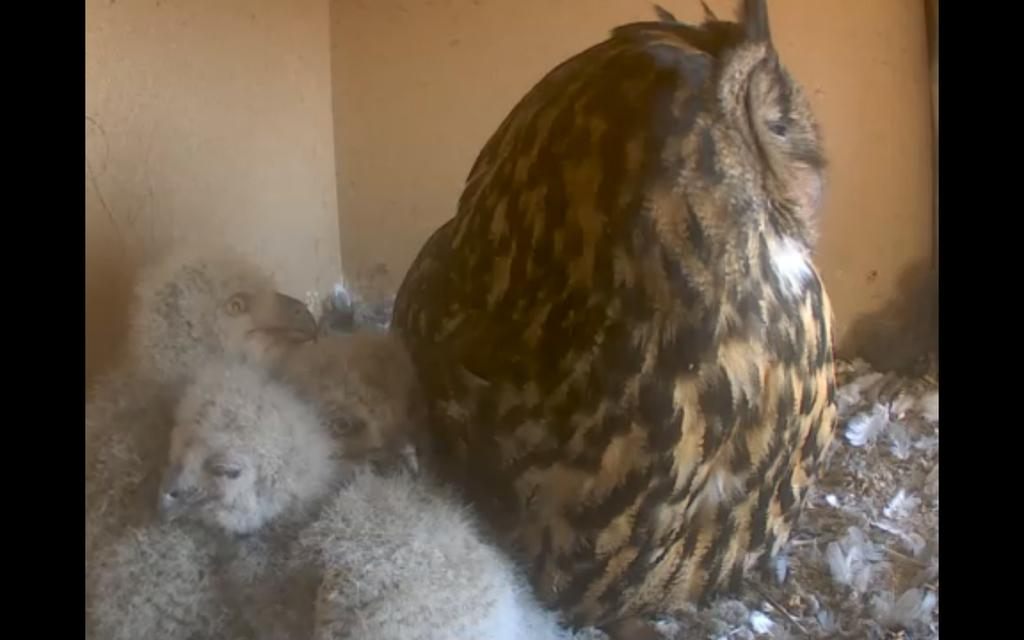What type of animals can be seen in the image? There are birds in the image. Where are the birds located in relation to the wall? The birds are in front of a wall. What color are the bikes in the image? There are no bikes present in the image; it features birds in front of a wall. 